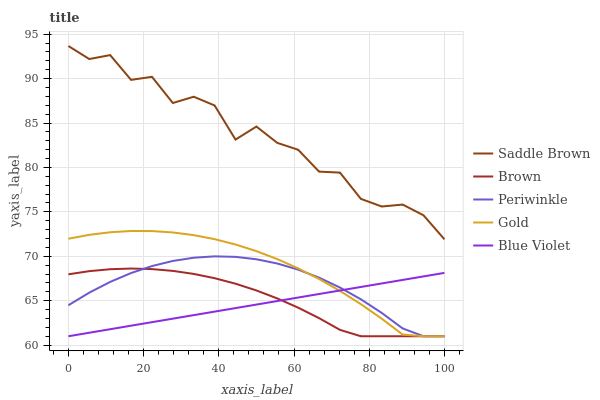Does Blue Violet have the minimum area under the curve?
Answer yes or no. Yes. Does Saddle Brown have the maximum area under the curve?
Answer yes or no. Yes. Does Brown have the minimum area under the curve?
Answer yes or no. No. Does Brown have the maximum area under the curve?
Answer yes or no. No. Is Blue Violet the smoothest?
Answer yes or no. Yes. Is Saddle Brown the roughest?
Answer yes or no. Yes. Is Brown the smoothest?
Answer yes or no. No. Is Brown the roughest?
Answer yes or no. No. Does Saddle Brown have the lowest value?
Answer yes or no. No. Does Brown have the highest value?
Answer yes or no. No. Is Brown less than Saddle Brown?
Answer yes or no. Yes. Is Saddle Brown greater than Gold?
Answer yes or no. Yes. Does Brown intersect Saddle Brown?
Answer yes or no. No. 